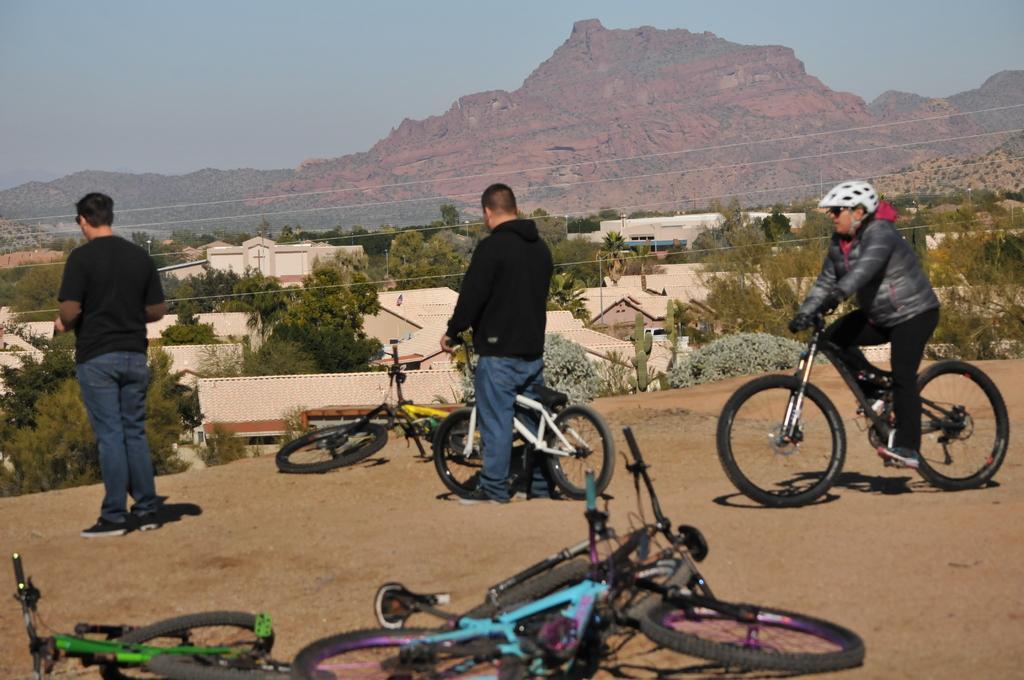Please provide a concise description of this image. Left a man is standing and the middle a man is holding a bicycle in the right a man is riding a bicycle. At the top there are hills. 